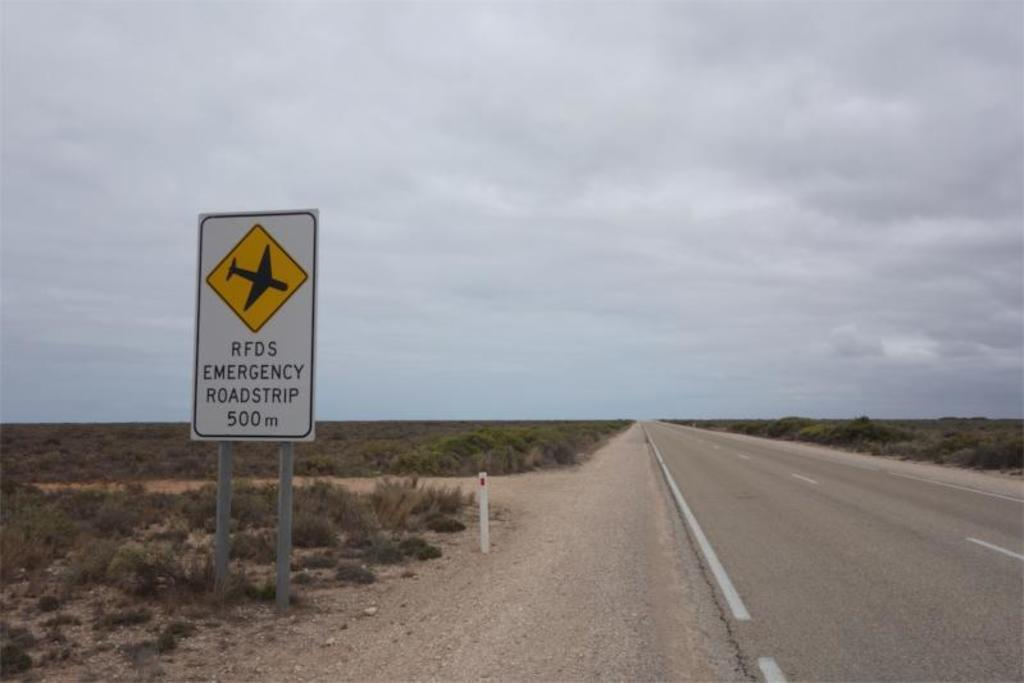<image>
Share a concise interpretation of the image provided. A RFDS Emergency roadstrip is 500 meters away. 